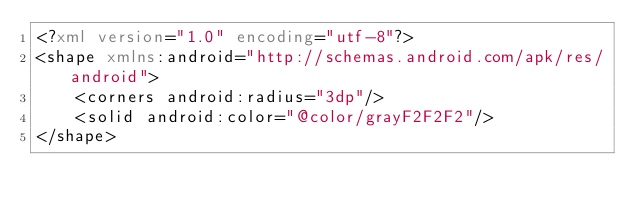<code> <loc_0><loc_0><loc_500><loc_500><_XML_><?xml version="1.0" encoding="utf-8"?>
<shape xmlns:android="http://schemas.android.com/apk/res/android">
    <corners android:radius="3dp"/>
    <solid android:color="@color/grayF2F2F2"/>
</shape></code> 